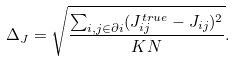<formula> <loc_0><loc_0><loc_500><loc_500>\Delta _ { J } = \sqrt { \frac { \sum _ { i , j \in \partial i } ( J _ { i j } ^ { t r u e } - J _ { i j } ) ^ { 2 } } { K N } } .</formula> 